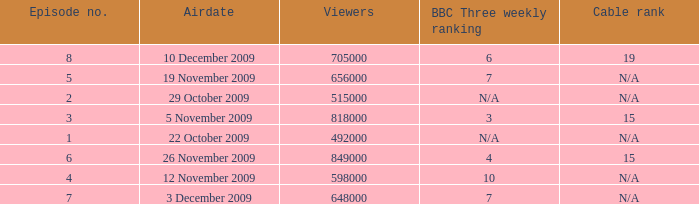How many viewers were there for airdate is 22 october 2009? 492000.0. 